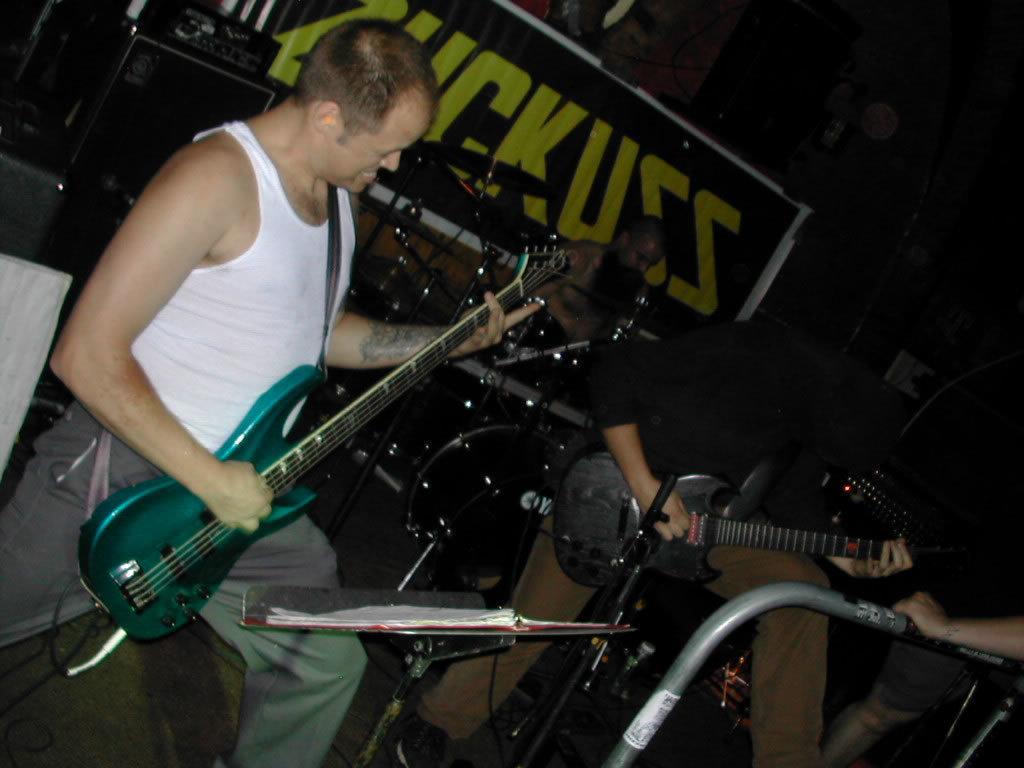Describe this image in one or two sentences. In the middle of the image there is a drum and there is a man sitting. Bottom right side of the image there is a man standing and playing guitar. Bottom left side of the image there is a man standing and playing guitar. Top left side of the image there are some electronic devices. Top right side of the image there is a banner. 